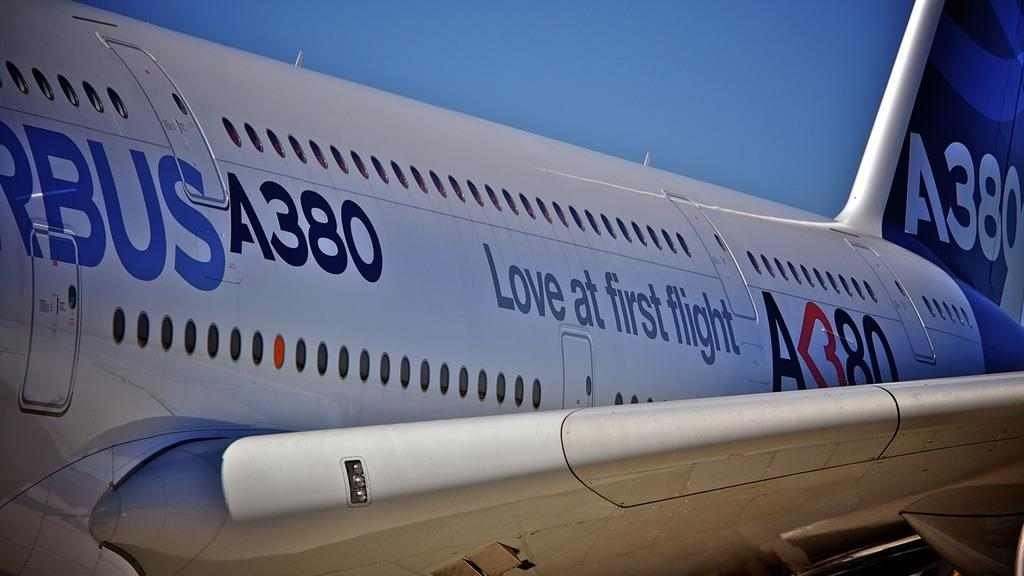<image>
Share a concise interpretation of the image provided. an A380 Airbus with Love at First Flight on the side 